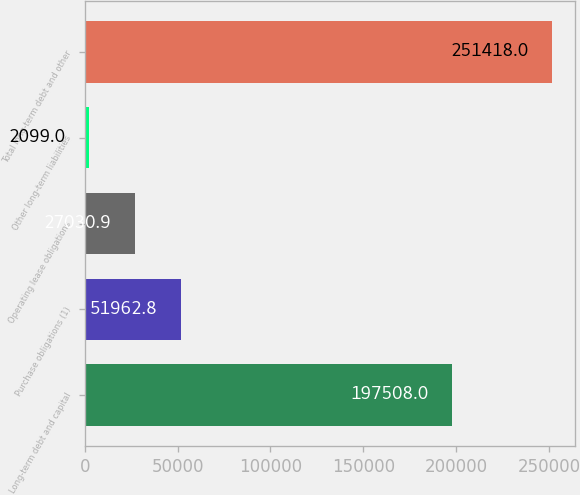Convert chart to OTSL. <chart><loc_0><loc_0><loc_500><loc_500><bar_chart><fcel>Long-term debt and capital<fcel>Purchase obligations (1)<fcel>Operating lease obligations<fcel>Other long-term liabilities<fcel>Total long-term debt and other<nl><fcel>197508<fcel>51962.8<fcel>27030.9<fcel>2099<fcel>251418<nl></chart> 